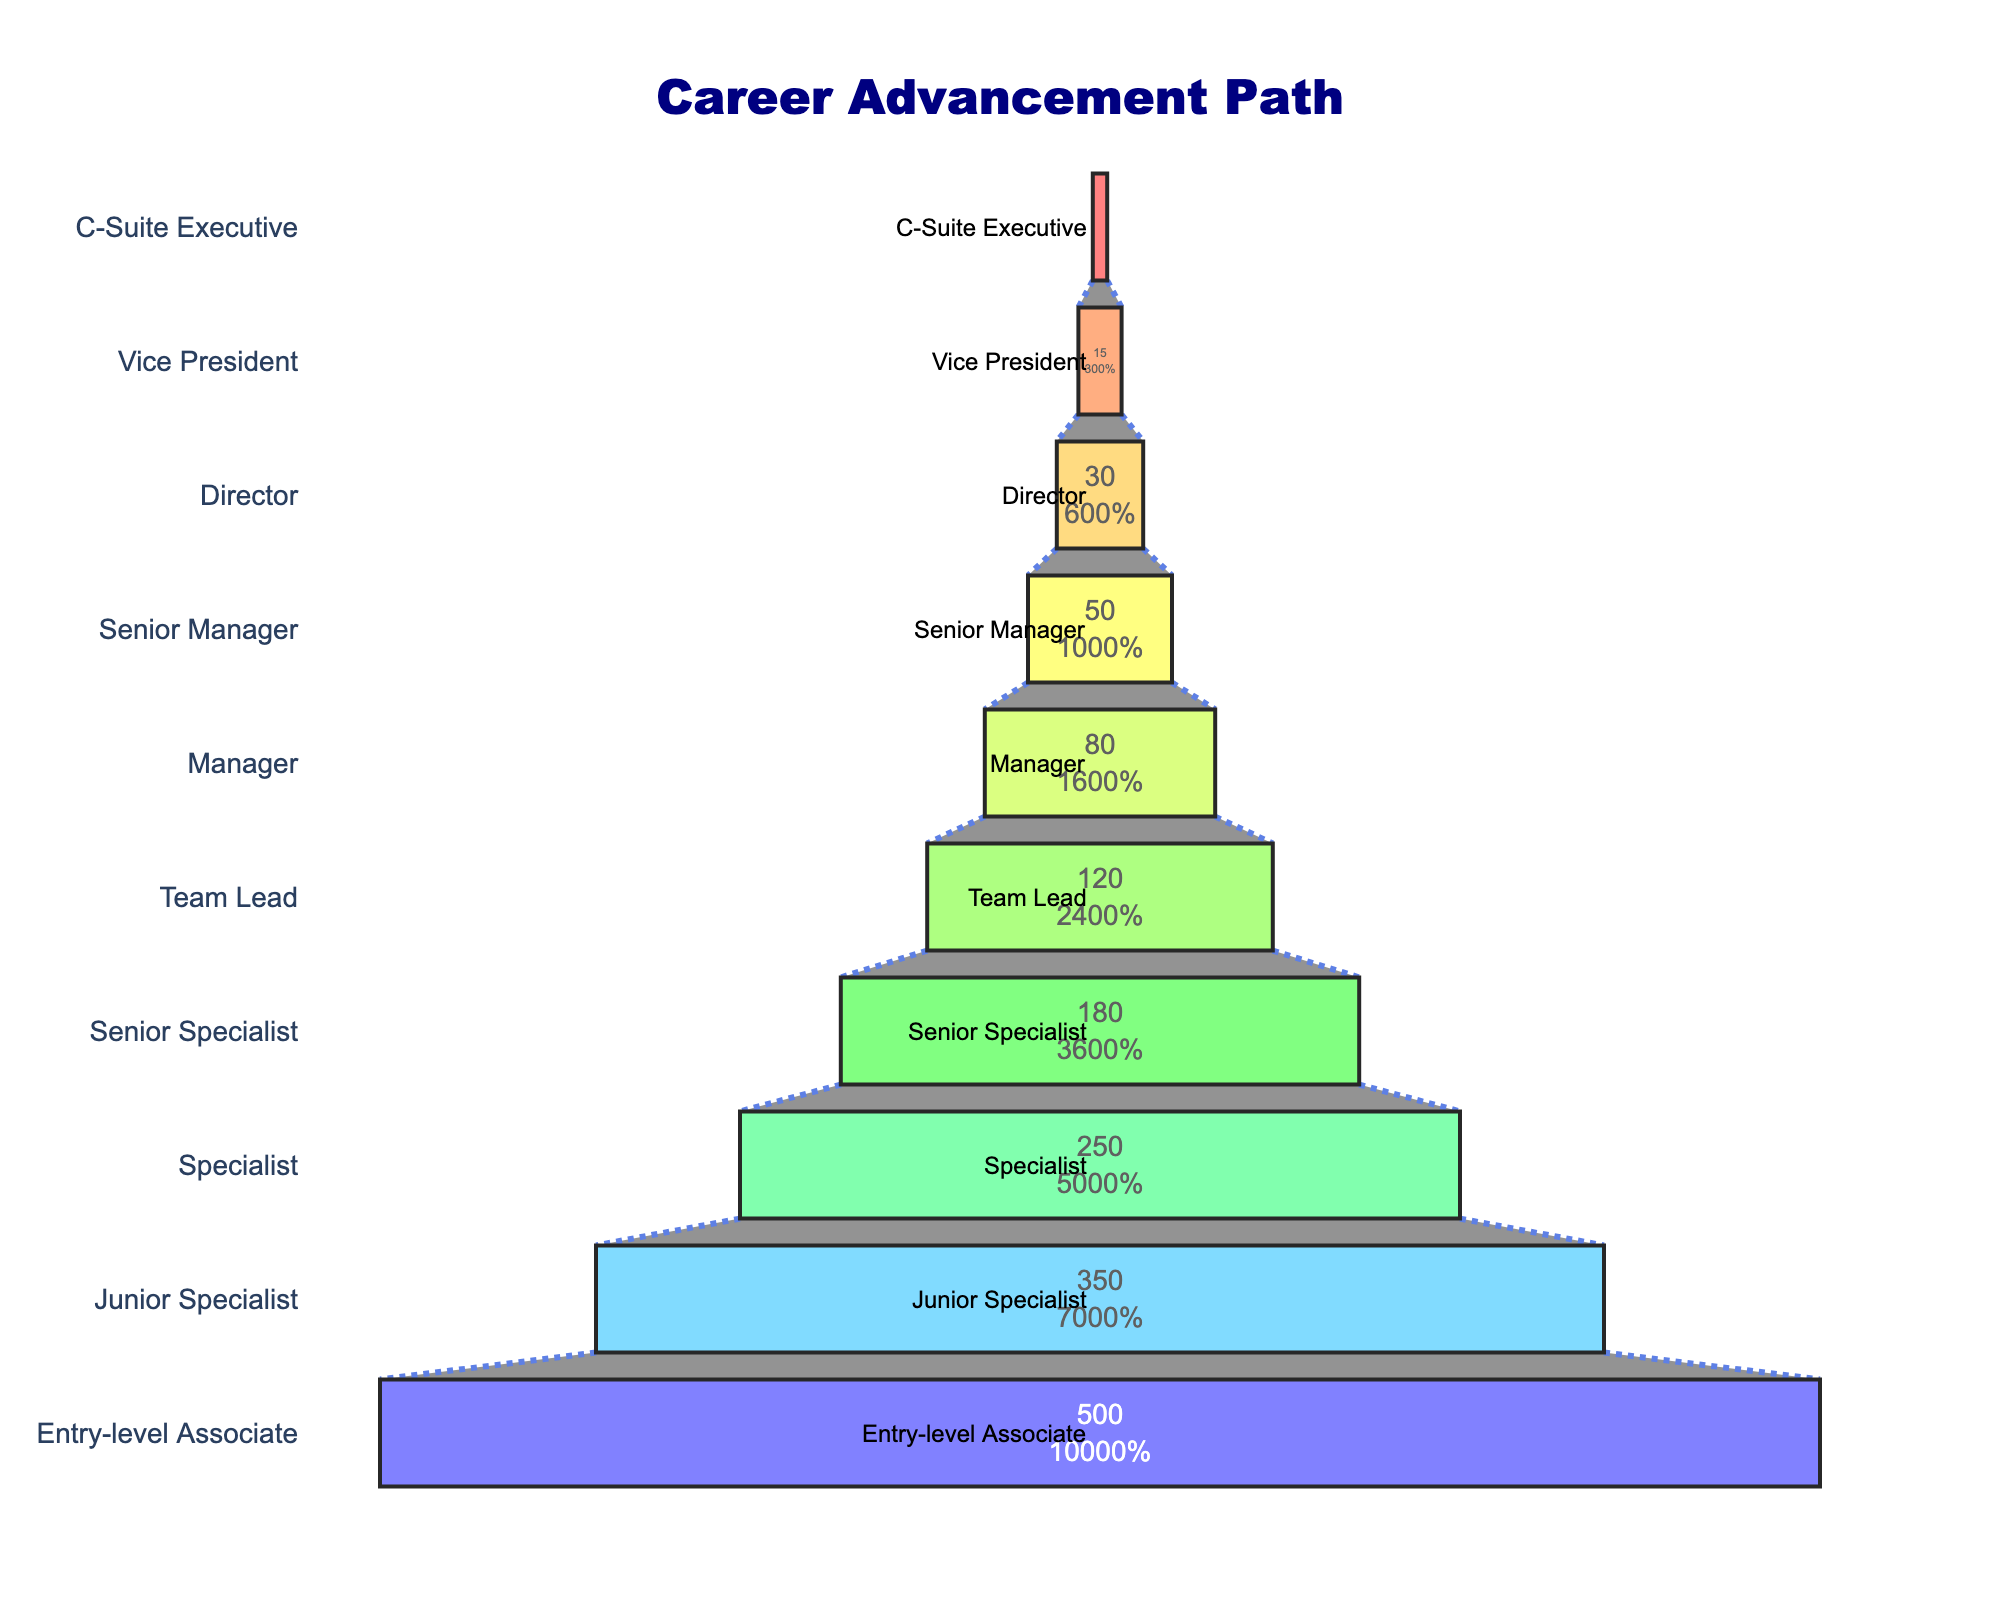What is the title of the chart? The title of the chart is located at the top of the figure. It reads "Career Advancement Path."
Answer: Career Advancement Path How many entry-level associates are there? The number of entry-level associates is shown in the bar at the bottom of the funnel chart. It specifically mentions the value "500" next to the 'Entry-level Associate' label.
Answer: 500 By how many employees does the count decrease from 'Specialist' to 'Senior Specialist'? To find the decrease, look at the number of employees for 'Specialist' (250) and 'Senior Specialist' (180). Subtract 180 from 250 to get the difference.
Answer: 70 Which level has the highest number of employees? The position at the bottom of the funnel typically represents the level with the highest number of employees. Here, 'Entry-level Associate' has 500 employees.
Answer: Entry-level Associate What percentage of initial employees remain at the 'Manager' level? To find the percentage, look at the 'Manager' level and note both the value and the percentage provided inside the bar. It shows the percentage compared to the initial (entry-level) value.
Answer: 16% What is the total number of employees at the 'Director' and 'Vice President' levels combined? Add the number of employees at 'Director' (30) and 'Vice President' (15). So, 30 + 15 equals 45.
Answer: 45 How does the number of 'Junior Specialists' compare to 'Team Leads'? Compare the values of 'Junior Specialist' (350) and 'Team Lead' (120). The number of 'Junior Specialists' is greater than 'Team Leads'.
Answer: Junior Specialist > Team Lead What is the trend observed as we move from 'Entry-level Associate' to 'C-Suite Executive'? The trend shows a diminishing number of employees as we move upward through the levels, starting from 500 at the entry-level and reducing to 5 at the C-Suite Executive level.
Answer: Decreasing number of employees What is the difference in the number of employees between 'Senior Manager' and 'Vice President'? Subtract the number of employees in 'Vice President' (15) from 'Senior Manager' (50). Therefore, 50 - 15 equals 35.
Answer: 35 